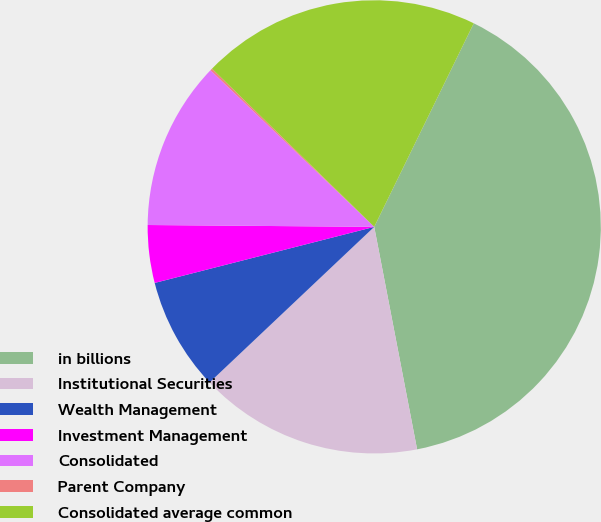<chart> <loc_0><loc_0><loc_500><loc_500><pie_chart><fcel>in billions<fcel>Institutional Securities<fcel>Wealth Management<fcel>Investment Management<fcel>Consolidated<fcel>Parent Company<fcel>Consolidated average common<nl><fcel>39.73%<fcel>15.98%<fcel>8.07%<fcel>4.11%<fcel>12.02%<fcel>0.15%<fcel>19.94%<nl></chart> 